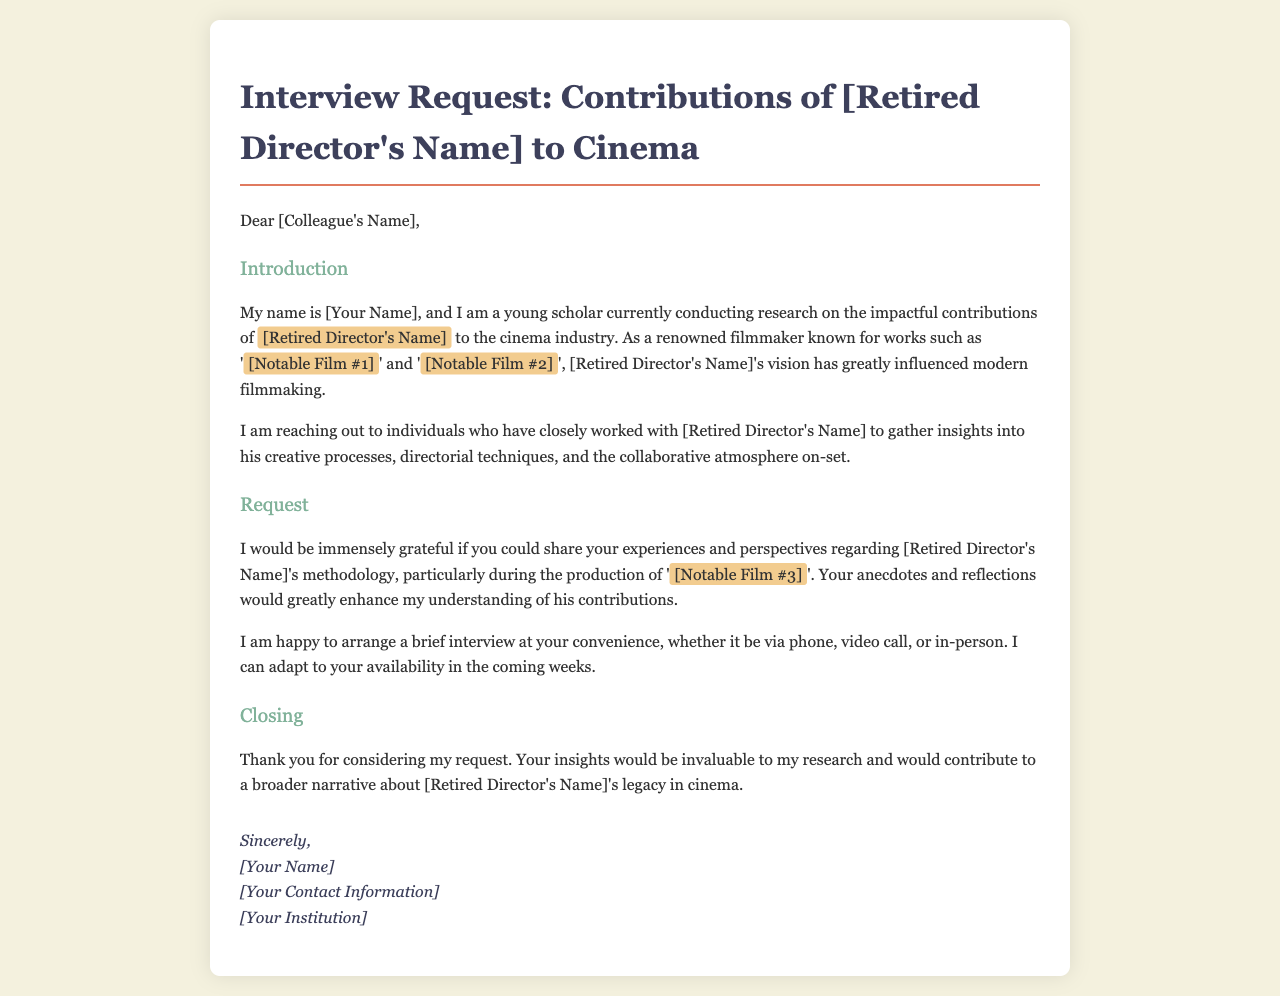What is the purpose of the email? The email's purpose is to request an interview with former colleagues of the retired director to gather insights into his contributions to cinema.
Answer: Interview request Who is the email addressed to? The email is addressed to individuals who have closely worked with the retired director.
Answer: [Colleague's Name] What is the name of the retired director mentioned? The email discusses the contributions of a specific retired director, whose name is not provided in the text but is marked for input.
Answer: [Retired Director's Name] Which film is specifically mentioned in the request for insights? The email asks for experiences regarding the methodology of the retired director during the production of a notable film.
Answer: [Notable Film #3] What type of meeting does the sender offer for the interview? The sender offers multiple options for the interview format to accommodate the recipient's availability.
Answer: Phone, video call, or in-person What is the sender's role as mentioned in the email? The sender introduces themselves as a young scholar conducting research on the retired director's contributions to cinema.
Answer: Young scholar What is included in the closing section of the email? The closing section thanks the recipient for considering the request and emphasizes the value of their insights to the research.
Answer: Thank you for considering my request 